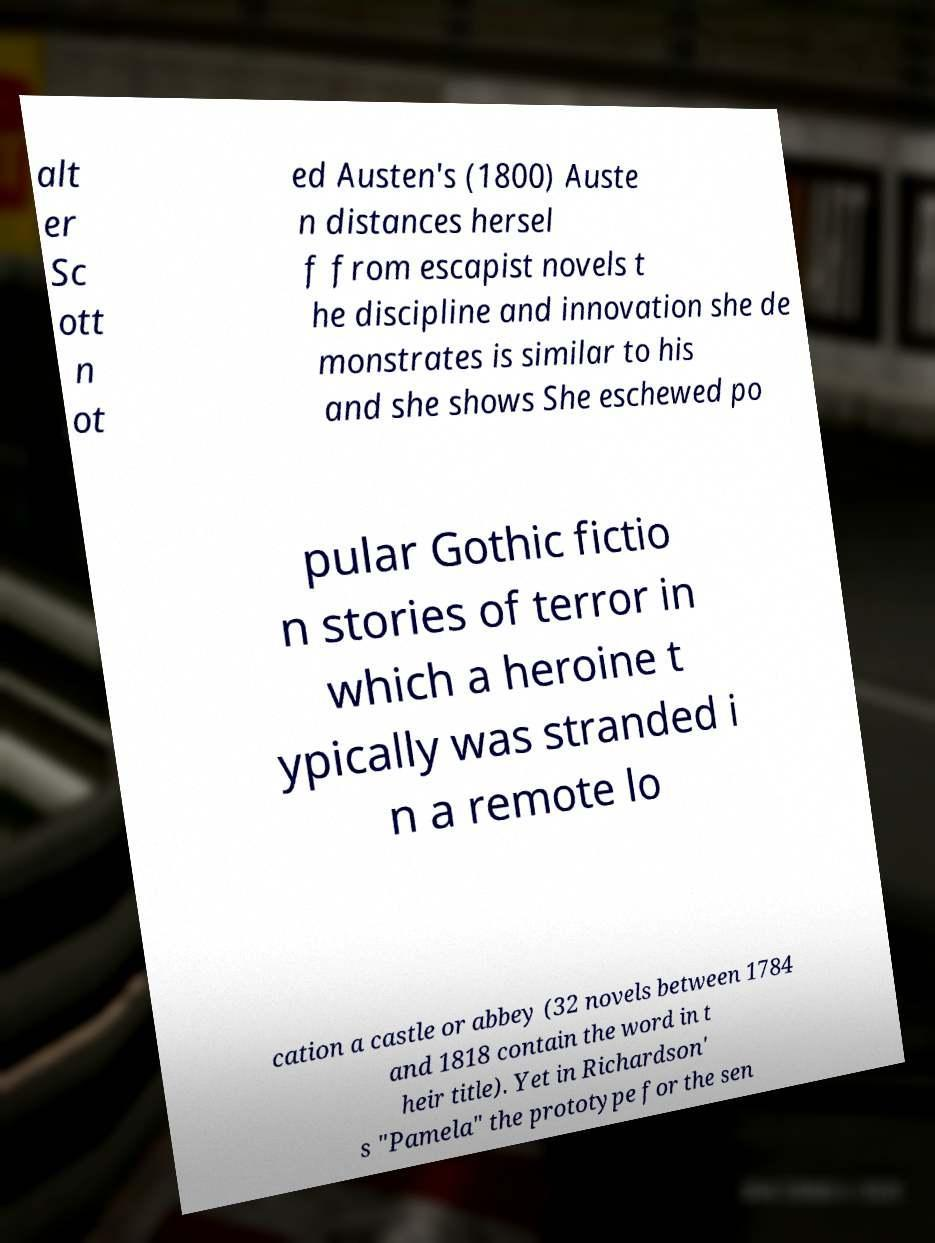Please read and relay the text visible in this image. What does it say? alt er Sc ott n ot ed Austen's (1800) Auste n distances hersel f from escapist novels t he discipline and innovation she de monstrates is similar to his and she shows She eschewed po pular Gothic fictio n stories of terror in which a heroine t ypically was stranded i n a remote lo cation a castle or abbey (32 novels between 1784 and 1818 contain the word in t heir title). Yet in Richardson' s "Pamela" the prototype for the sen 